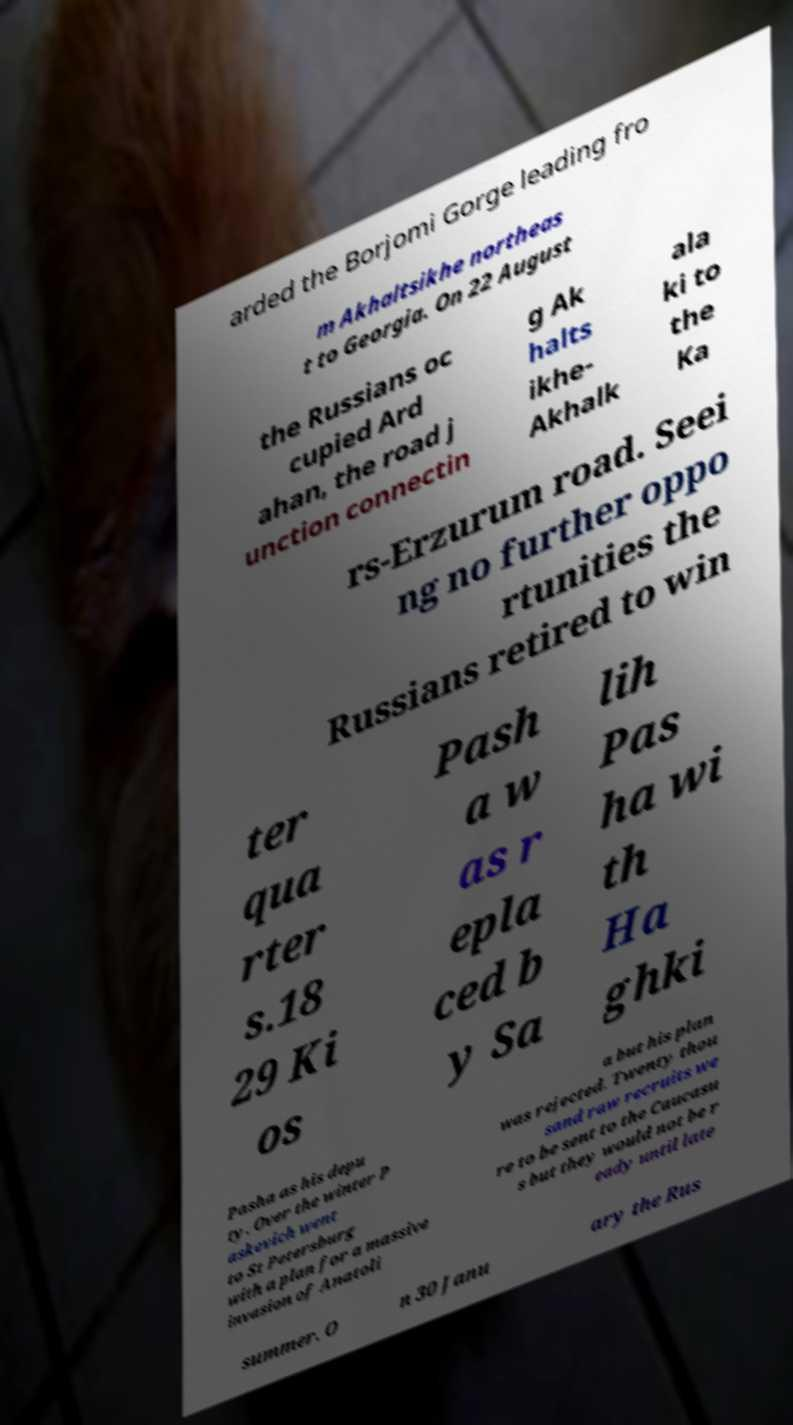Can you read and provide the text displayed in the image?This photo seems to have some interesting text. Can you extract and type it out for me? arded the Borjomi Gorge leading fro m Akhaltsikhe northeas t to Georgia. On 22 August the Russians oc cupied Ard ahan, the road j unction connectin g Ak halts ikhe- Akhalk ala ki to the Ka rs-Erzurum road. Seei ng no further oppo rtunities the Russians retired to win ter qua rter s.18 29 Ki os Pash a w as r epla ced b y Sa lih Pas ha wi th Ha ghki Pasha as his depu ty. Over the winter P askevich went to St Petersburg with a plan for a massive invasion of Anatoli a but his plan was rejected. Twenty thou sand raw recruits we re to be sent to the Caucasu s but they would not be r eady until late summer. O n 30 Janu ary the Rus 